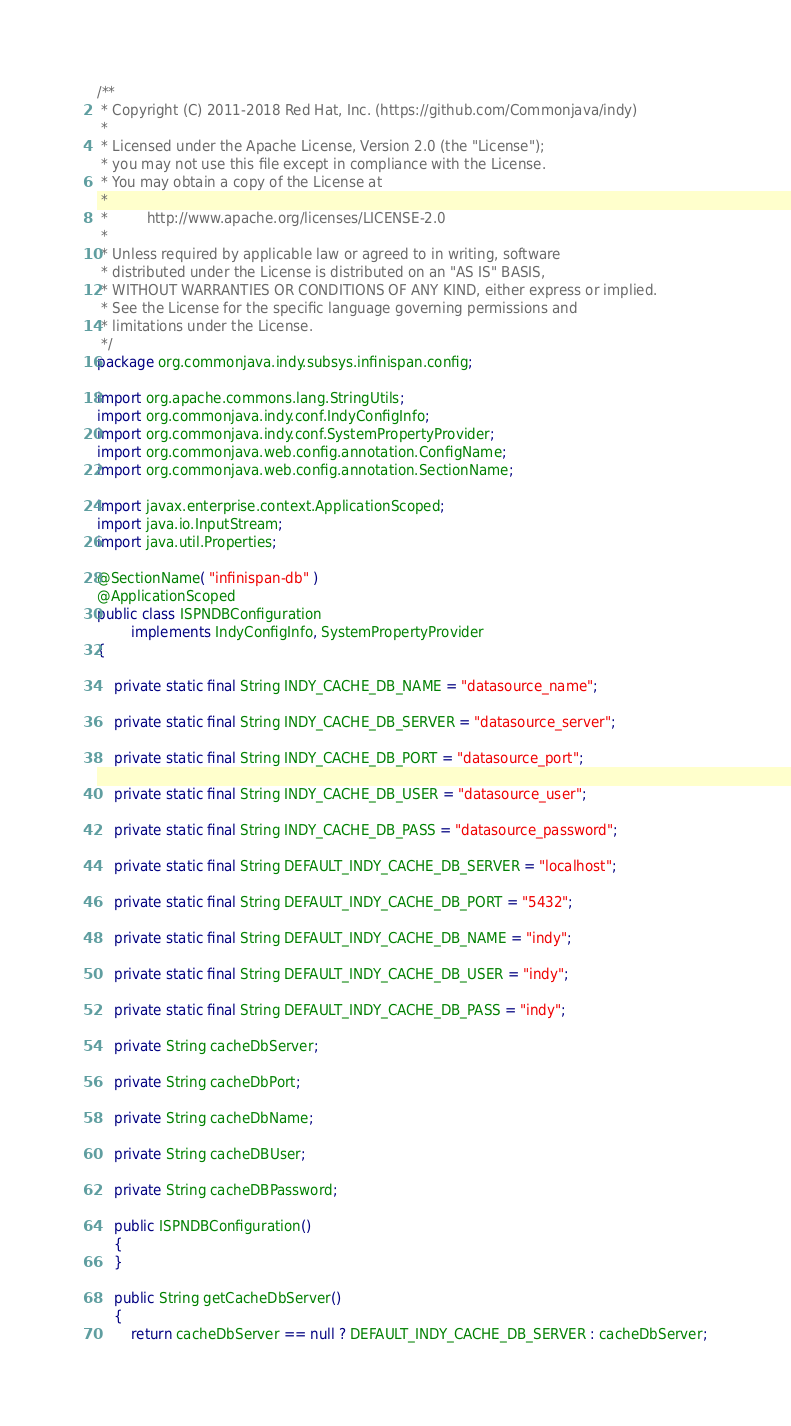<code> <loc_0><loc_0><loc_500><loc_500><_Java_>/**
 * Copyright (C) 2011-2018 Red Hat, Inc. (https://github.com/Commonjava/indy)
 *
 * Licensed under the Apache License, Version 2.0 (the "License");
 * you may not use this file except in compliance with the License.
 * You may obtain a copy of the License at
 *
 *         http://www.apache.org/licenses/LICENSE-2.0
 *
 * Unless required by applicable law or agreed to in writing, software
 * distributed under the License is distributed on an "AS IS" BASIS,
 * WITHOUT WARRANTIES OR CONDITIONS OF ANY KIND, either express or implied.
 * See the License for the specific language governing permissions and
 * limitations under the License.
 */
package org.commonjava.indy.subsys.infinispan.config;

import org.apache.commons.lang.StringUtils;
import org.commonjava.indy.conf.IndyConfigInfo;
import org.commonjava.indy.conf.SystemPropertyProvider;
import org.commonjava.web.config.annotation.ConfigName;
import org.commonjava.web.config.annotation.SectionName;

import javax.enterprise.context.ApplicationScoped;
import java.io.InputStream;
import java.util.Properties;

@SectionName( "infinispan-db" )
@ApplicationScoped
public class ISPNDBConfiguration
        implements IndyConfigInfo, SystemPropertyProvider
{

    private static final String INDY_CACHE_DB_NAME = "datasource_name";

    private static final String INDY_CACHE_DB_SERVER = "datasource_server";

    private static final String INDY_CACHE_DB_PORT = "datasource_port";

    private static final String INDY_CACHE_DB_USER = "datasource_user";

    private static final String INDY_CACHE_DB_PASS = "datasource_password";

    private static final String DEFAULT_INDY_CACHE_DB_SERVER = "localhost";

    private static final String DEFAULT_INDY_CACHE_DB_PORT = "5432";

    private static final String DEFAULT_INDY_CACHE_DB_NAME = "indy";

    private static final String DEFAULT_INDY_CACHE_DB_USER = "indy";

    private static final String DEFAULT_INDY_CACHE_DB_PASS = "indy";

    private String cacheDbServer;

    private String cacheDbPort;

    private String cacheDbName;

    private String cacheDBUser;

    private String cacheDBPassword;

    public ISPNDBConfiguration()
    {
    }

    public String getCacheDbServer()
    {
        return cacheDbServer == null ? DEFAULT_INDY_CACHE_DB_SERVER : cacheDbServer;</code> 